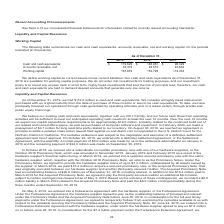According to Alarmcom Holdings's financial document, How did the company define working capital? current assets minus current liabilities.. The document states: "We define working capital as current assets minus current liabilities. Our cash and cash equivalents as of December 31, 2019 are available for working..." Also, What was the working capital in 2019? According to the financial document, 167,879 (in thousands). The relevant text states: "eivable, net 76,373 49,510 40,634 Working capital 167,879 152,793 119,433..." Also, Which years does the table provide information for the company's cash and cash equivalents, accounts receivable, net and working capital for? The document contains multiple relevant values: 2019, 2018, 2017. From the document: "As of December 31, 2019 2018 2017 Cash and cash equivalents $ 119,629 $ 146,061 $ 96,329 Accounts receivable, net 76,373 49,510 40,63 As of December 3..." Also, can you calculate: What was the change in working capital between 2017 and 2018? Based on the calculation: 152,793-119,433, the result is 33360 (in thousands). This is based on the information: "373 49,510 40,634 Working capital 167,879 152,793 119,433 net 76,373 49,510 40,634 Working capital 167,879 152,793 119,433..." The key data points involved are: 119,433, 152,793. Also, How many years did net accounts receivables exceed $50,000 thousand? Based on the analysis, there are 1 instances. The counting process: 2019. Also, can you calculate: What was the percentage change in Cash and cash equivalents between 2018 and 2019? To answer this question, I need to perform calculations using the financial data. The calculation is: (119,629-146,061)/146,061, which equals -18.1 (percentage). This is based on the information: "9 2018 2017 Cash and cash equivalents $ 119,629 $ 146,061 $ 96,329 Accounts receivable, net 76,373 49,510 40,634 Working capital 167,879 152,793 119,433 er 31, 2019 2018 2017 Cash and cash equivalents..." The key data points involved are: 119,629, 146,061. 